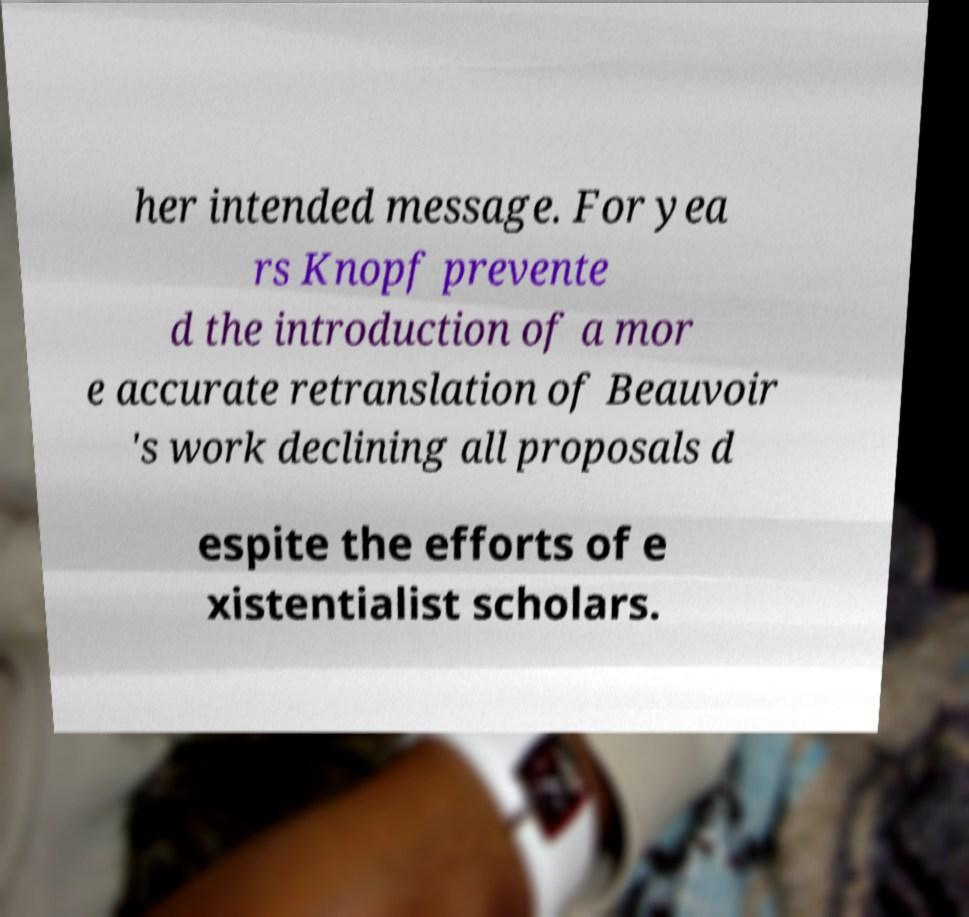Could you extract and type out the text from this image? her intended message. For yea rs Knopf prevente d the introduction of a mor e accurate retranslation of Beauvoir 's work declining all proposals d espite the efforts of e xistentialist scholars. 